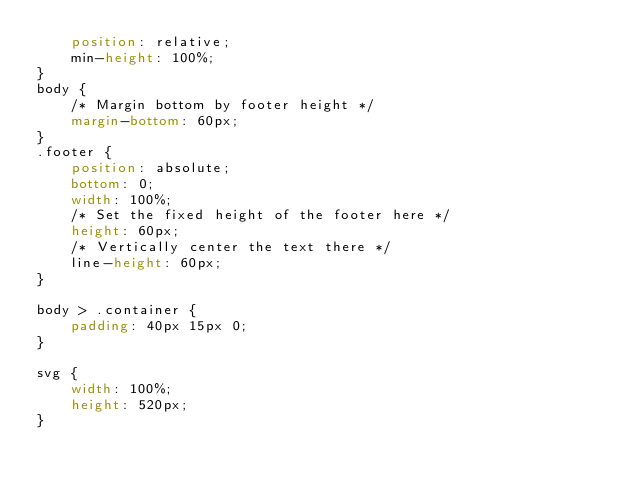Convert code to text. <code><loc_0><loc_0><loc_500><loc_500><_CSS_>    position: relative;
    min-height: 100%;
}
body {
    /* Margin bottom by footer height */
    margin-bottom: 60px;
}
.footer {
    position: absolute;
    bottom: 0;
    width: 100%;
    /* Set the fixed height of the footer here */
    height: 60px;
    /* Vertically center the text there */
    line-height: 60px;
}

body > .container {
    padding: 40px 15px 0;
}

svg {
    width: 100%;
    height: 520px;
}</code> 